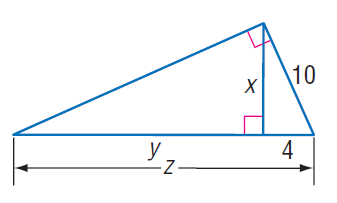Answer the mathemtical geometry problem and directly provide the correct option letter.
Question: Find y.
Choices: A: 14 B: 17 C: 21 D: 25 C 